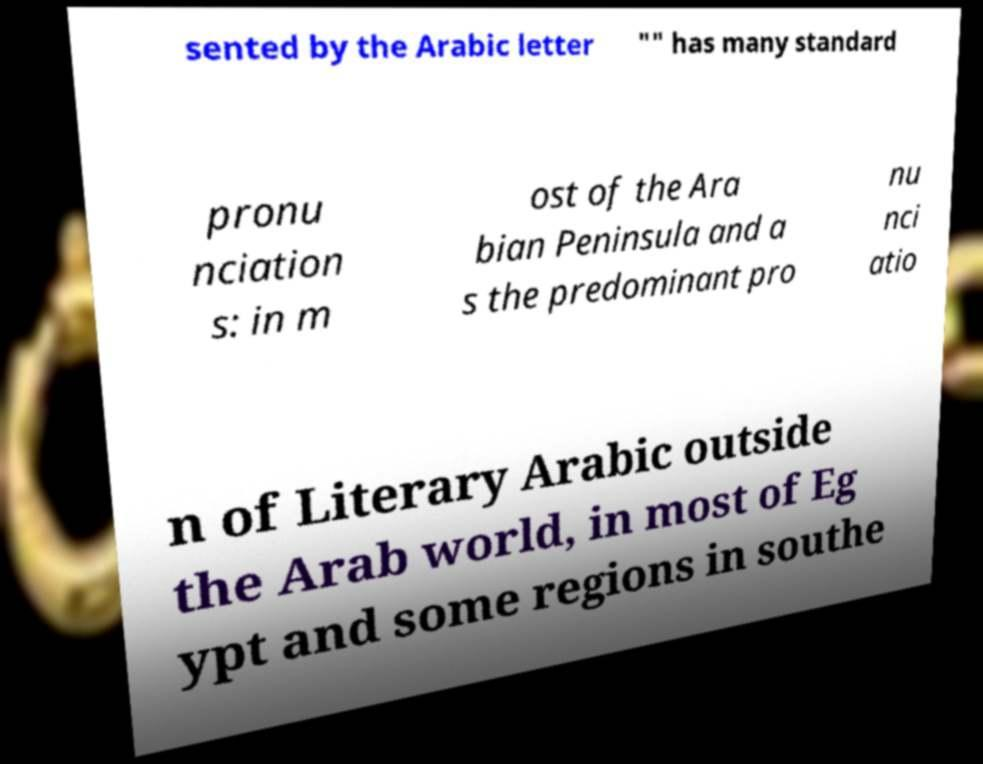Could you extract and type out the text from this image? sented by the Arabic letter "" has many standard pronu nciation s: in m ost of the Ara bian Peninsula and a s the predominant pro nu nci atio n of Literary Arabic outside the Arab world, in most of Eg ypt and some regions in southe 